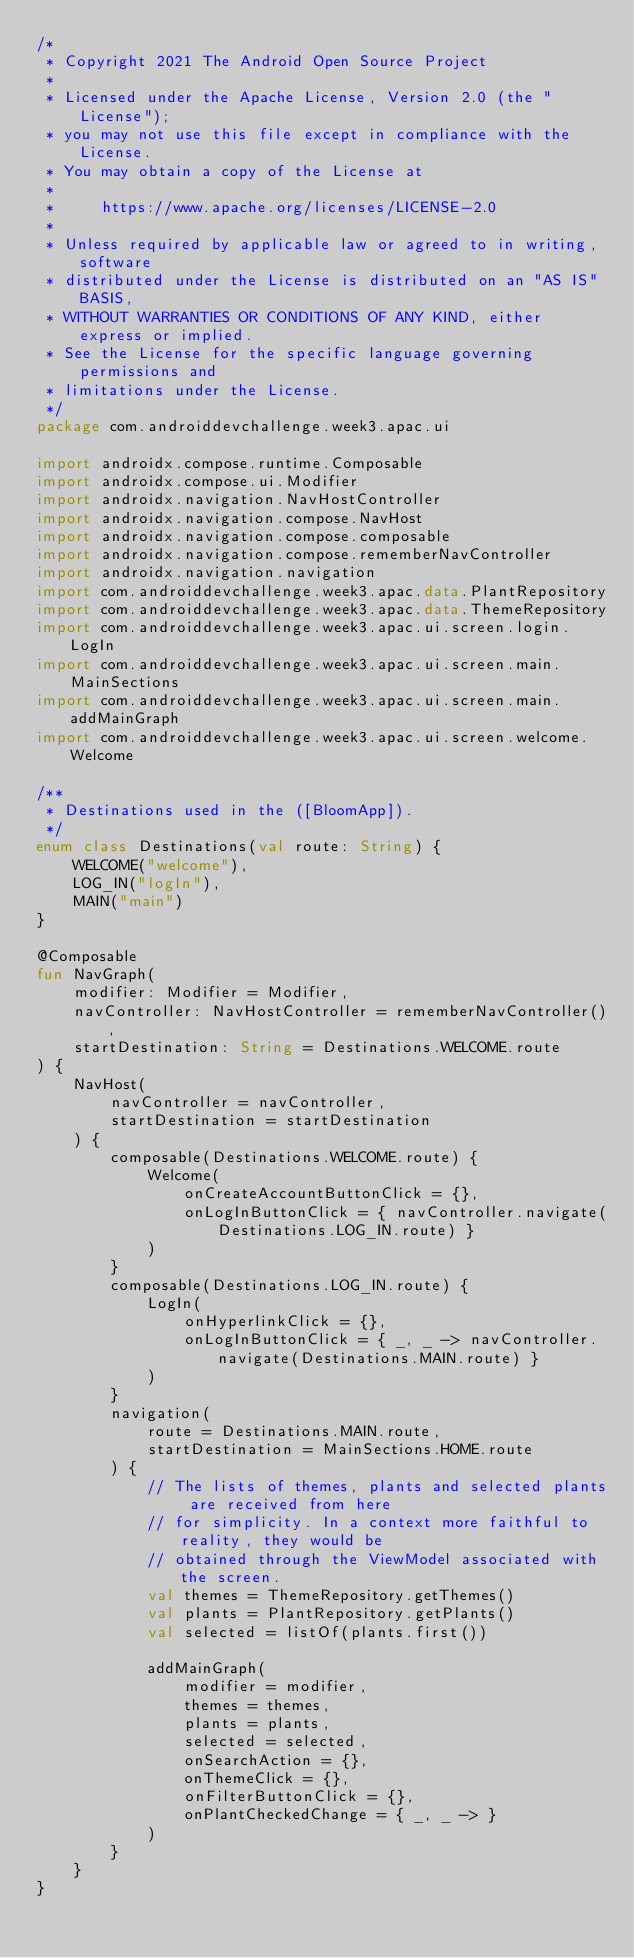Convert code to text. <code><loc_0><loc_0><loc_500><loc_500><_Kotlin_>/*
 * Copyright 2021 The Android Open Source Project
 *
 * Licensed under the Apache License, Version 2.0 (the "License");
 * you may not use this file except in compliance with the License.
 * You may obtain a copy of the License at
 *
 *     https://www.apache.org/licenses/LICENSE-2.0
 *
 * Unless required by applicable law or agreed to in writing, software
 * distributed under the License is distributed on an "AS IS" BASIS,
 * WITHOUT WARRANTIES OR CONDITIONS OF ANY KIND, either express or implied.
 * See the License for the specific language governing permissions and
 * limitations under the License.
 */
package com.androiddevchallenge.week3.apac.ui

import androidx.compose.runtime.Composable
import androidx.compose.ui.Modifier
import androidx.navigation.NavHostController
import androidx.navigation.compose.NavHost
import androidx.navigation.compose.composable
import androidx.navigation.compose.rememberNavController
import androidx.navigation.navigation
import com.androiddevchallenge.week3.apac.data.PlantRepository
import com.androiddevchallenge.week3.apac.data.ThemeRepository
import com.androiddevchallenge.week3.apac.ui.screen.login.LogIn
import com.androiddevchallenge.week3.apac.ui.screen.main.MainSections
import com.androiddevchallenge.week3.apac.ui.screen.main.addMainGraph
import com.androiddevchallenge.week3.apac.ui.screen.welcome.Welcome

/**
 * Destinations used in the ([BloomApp]).
 */
enum class Destinations(val route: String) {
    WELCOME("welcome"),
    LOG_IN("logIn"),
    MAIN("main")
}

@Composable
fun NavGraph(
    modifier: Modifier = Modifier,
    navController: NavHostController = rememberNavController(),
    startDestination: String = Destinations.WELCOME.route
) {
    NavHost(
        navController = navController,
        startDestination = startDestination
    ) {
        composable(Destinations.WELCOME.route) {
            Welcome(
                onCreateAccountButtonClick = {},
                onLogInButtonClick = { navController.navigate(Destinations.LOG_IN.route) }
            )
        }
        composable(Destinations.LOG_IN.route) {
            LogIn(
                onHyperlinkClick = {},
                onLogInButtonClick = { _, _ -> navController.navigate(Destinations.MAIN.route) }
            )
        }
        navigation(
            route = Destinations.MAIN.route,
            startDestination = MainSections.HOME.route
        ) {
            // The lists of themes, plants and selected plants are received from here
            // for simplicity. In a context more faithful to reality, they would be
            // obtained through the ViewModel associated with the screen.
            val themes = ThemeRepository.getThemes()
            val plants = PlantRepository.getPlants()
            val selected = listOf(plants.first())

            addMainGraph(
                modifier = modifier,
                themes = themes,
                plants = plants,
                selected = selected,
                onSearchAction = {},
                onThemeClick = {},
                onFilterButtonClick = {},
                onPlantCheckedChange = { _, _ -> }
            )
        }
    }
}
</code> 